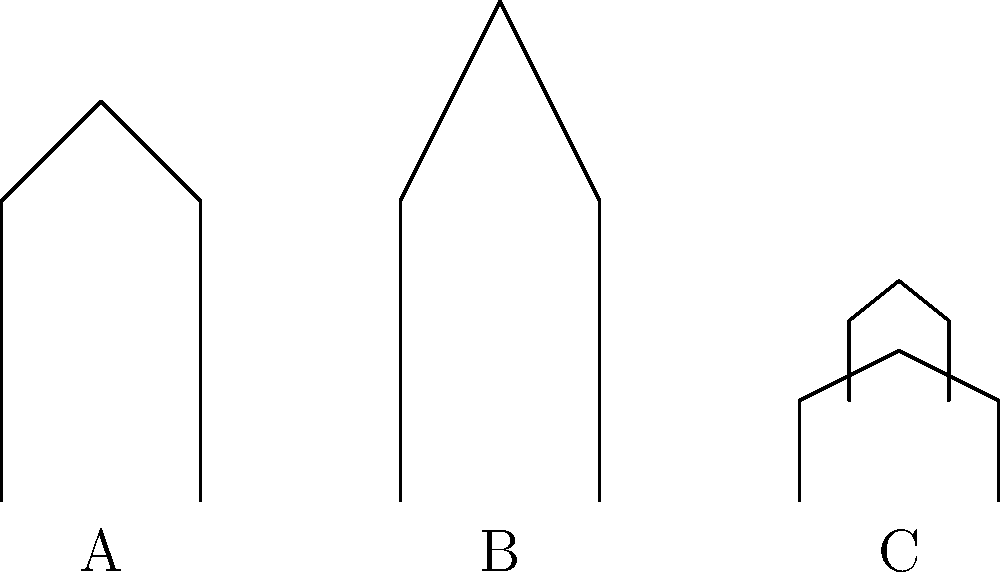The image above shows simplified line drawings of three religious structures: A (mosque minaret), B (church steeple), and C (pagoda). Which structure demonstrates the principle of vertical repetition most clearly, and how does this relate to its religious symbolism? Let's analyze each structure step-by-step:

1. Structure A (Mosque minaret):
   - Single vertical structure
   - Tapers towards the top
   - No clear repetition of elements

2. Structure B (Church steeple):
   - Single vertical structure
   - Comes to a point at the top
   - No clear repetition of elements

3. Structure C (Pagoda):
   - Two distinct levels
   - Each level has a similar shape (wider at the bottom, narrower at the top)
   - Clear repetition of the basic form

The pagoda (C) demonstrates vertical repetition most clearly. This architectural feature relates to its religious symbolism in several ways:

1. Representation of cosmic structure: In many Eastern religions, the multiple tiers of a pagoda represent different realms or levels of existence.

2. Spiritual ascension: The repetition of levels symbolizes the journey of spiritual growth and enlightenment, with each level representing a higher state of consciousness.

3. Sacred numbers: The number of tiers often corresponds to significant numbers in the religion (e.g., Buddha's Noble Eightfold Path in Buddhism).

4. Heaven and Earth connection: The vertical repetition emphasizes the connection between the earthly realm (bottom) and the heavenly realm (top).

This vertical repetition in pagodas contrasts with the singular upward thrust of minarets and church steeples, which symbolize a more direct connection between Earth and the divine in their respective traditions.
Answer: Pagoda (C); represents cosmic structure, spiritual ascension, sacred numbers, and Earth-Heaven connection. 